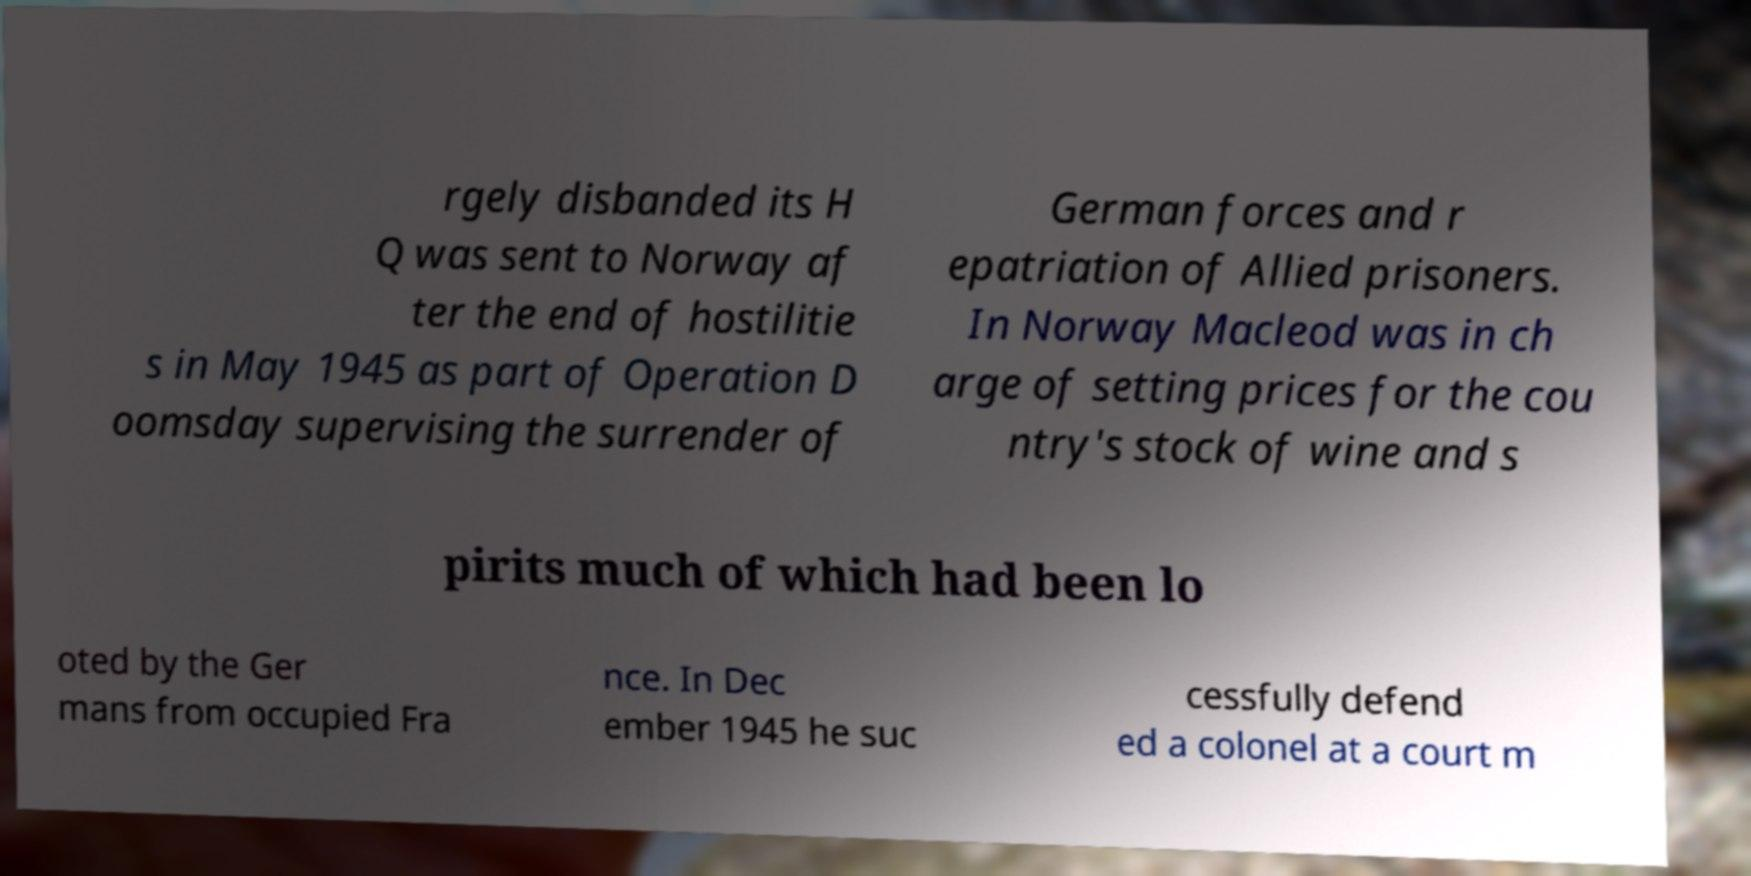Please identify and transcribe the text found in this image. rgely disbanded its H Q was sent to Norway af ter the end of hostilitie s in May 1945 as part of Operation D oomsday supervising the surrender of German forces and r epatriation of Allied prisoners. In Norway Macleod was in ch arge of setting prices for the cou ntry's stock of wine and s pirits much of which had been lo oted by the Ger mans from occupied Fra nce. In Dec ember 1945 he suc cessfully defend ed a colonel at a court m 